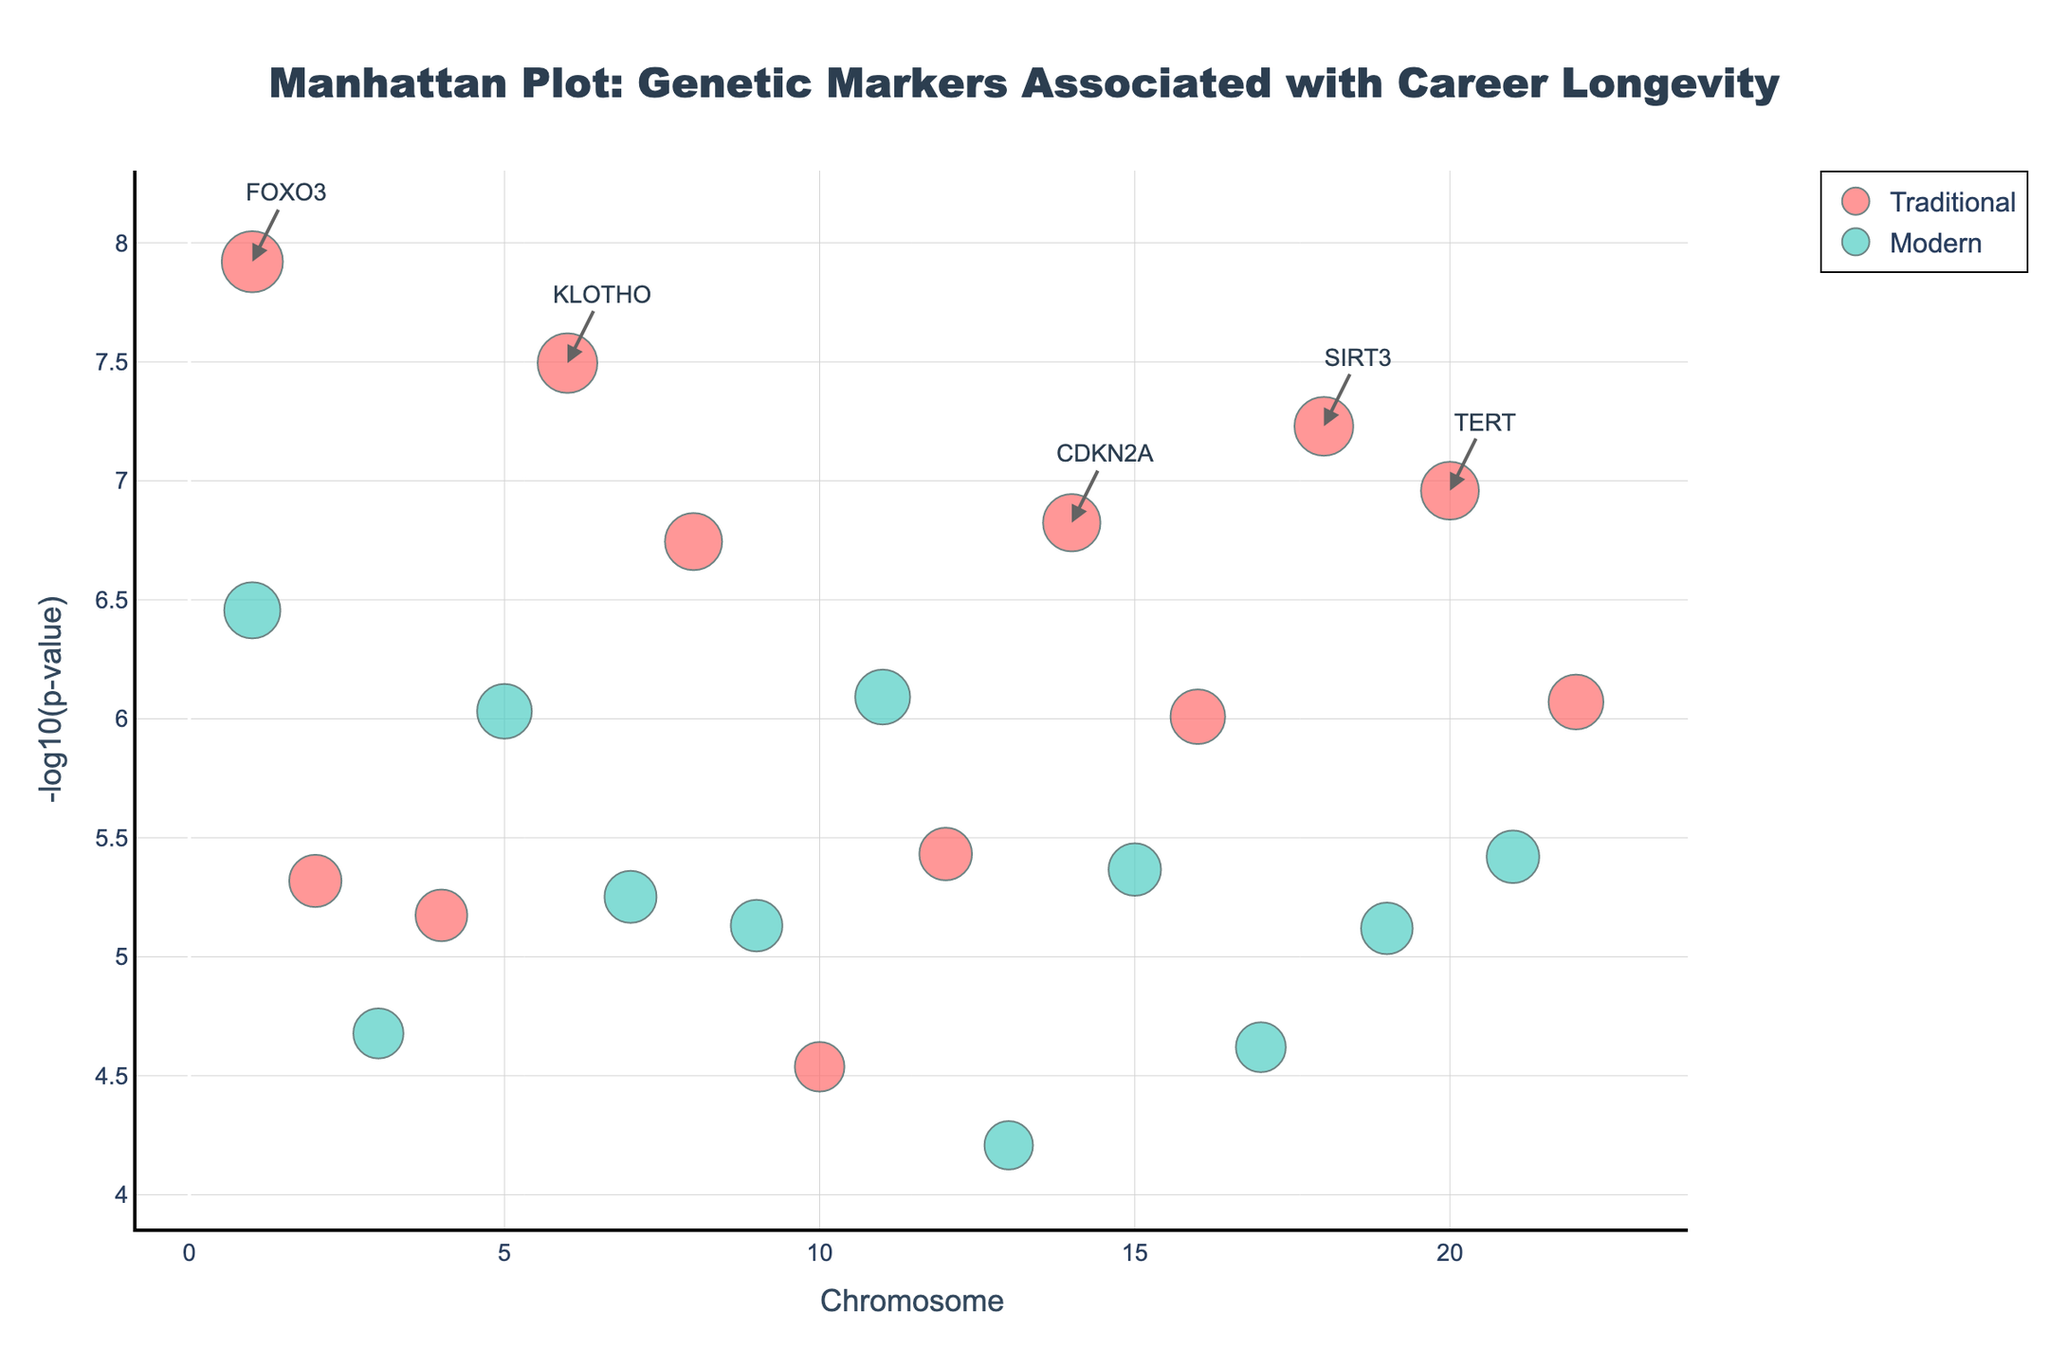What is the title of the plot? The title is located at the top of the figure. It reads "Manhattan Plot: Genetic Markers Associated with Career Longevity".
Answer: Manhattan Plot: Genetic Markers Associated with Career Longevity What are the two occupation types shown in the plot, and what colors represent them? The colors corresponding to the occupation types are mentioned in the legend of the plot. Traditional is represented by a reddish color, and Modern is represented by a teal color.
Answer: Traditional: red, Modern: teal How many genetic markers have a P-value less than 1e-6 for the Traditional occupation type? To determine this, we need to count the markers in the plot for the Traditional occupation type with a Y-axis value (which is -log10(P-value)) greater than 6. There are 6 such markers: FOXO3, SIRT3, KLOTHO, SOD2, CDKN2A, TERT.
Answer: 6 Which chromosome has the highest number of significant genetic markers for career longevity across both occupation types? We need to look at the x-axis and count the markers per chromosome. Chromosome 1 has the highest number of markers with 2 markers: FOXO3 (Traditional) and APOE (Modern).
Answer: Chromosome 1 What is the most significant genetic marker for the Modern occupation type? The significance of markers is represented by their Y-axis position, with higher being more significant. For Modern, the marker with the highest Y-axis value is CETP.
Answer: CETP Which gene appears on chromosome 10 and what is its occupation type? By referencing the positions on the x-axis (chromosomes) and looking at the associated genes, we find AKT1 appears on chromosome 10 and it is labeled under the Traditional occupation type.
Answer: AKT1, Traditional Are there more significant genetic markers for the Traditional occupation type or the Modern occupation type? To answer this, we count the markers above the significance threshold (-log10(P) > 6), Traditional has 6 such markers, and Modern has 5 such markers.
Answer: Traditional Comparing the genes FOXO3 and MTOR, which one has a higher -log10(p-value) and thus is more significant? By comparing their Y-axis positions directly, FOXO3 (Traditional) has a higher Y-axis value than MTOR (Modern).
Answer: FOXO3 How many genetic markers are exemplary labeled with gene names in the plot? Exemplary labeled gene names are noted with additional annotations in the plot. There are 5 such markers labeled in the plot.
Answer: 5 